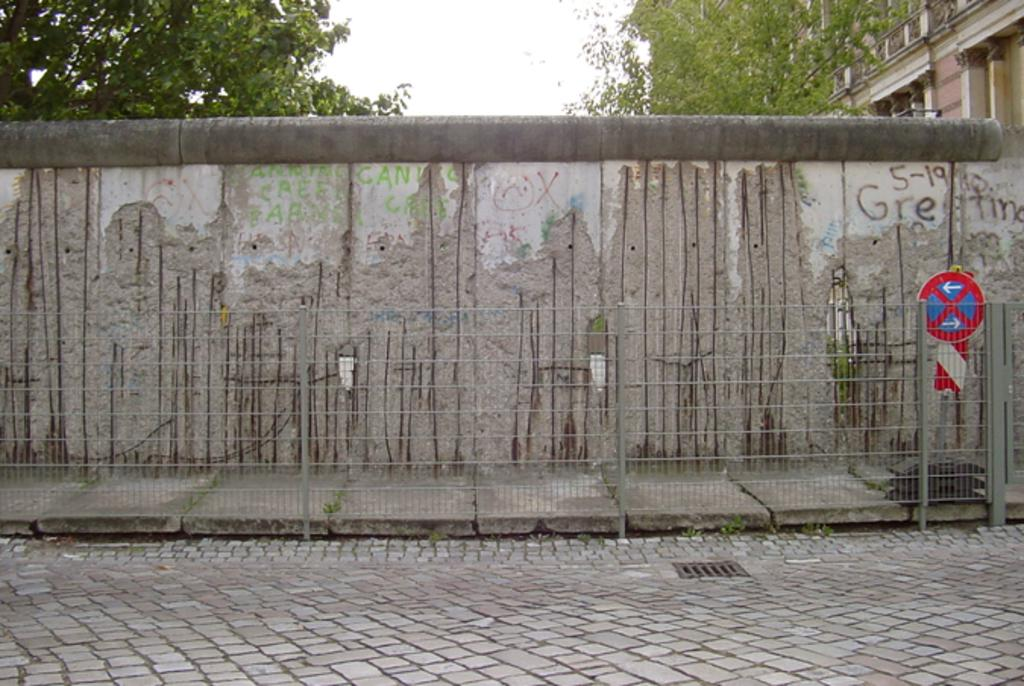What type of road is visible in the image? There is a brick road in the image. What kind of fencing can be seen in the image? There is a mesh fencing with poles in the image. What structures are visible in the background of the image? There is a wall, a sidewalk, a sign board, trees, sky, and a building visible in the background of the image. Can you tell me what language the ghost is speaking in the image? There is no ghost present in the image, so it is not possible to determine the language they might be speaking. 